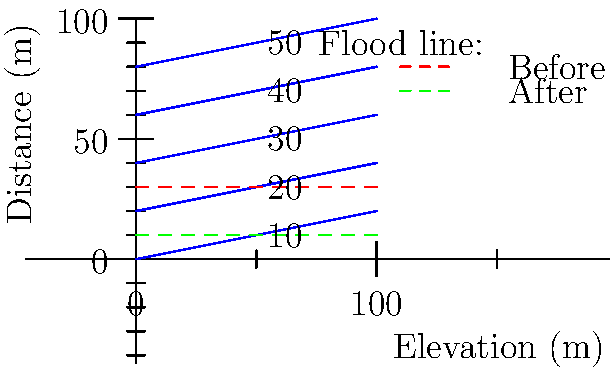Based on the topographical map showing contour lines and flood levels before and after the implementation of a new storm water management system, calculate the reduction in flood risk area (in square meters) for a 100m x 100m property. To calculate the reduction in flood risk area, we need to follow these steps:

1. Determine the flood level before and after the storm water management system:
   - Before: 30m elevation
   - After: 10m elevation

2. Calculate the area affected by flooding before the system:
   - The flood line intersects the 30m contour line
   - Area = $100\text{m} \times 30\text{m} = 3000\text{m}^2$

3. Calculate the area affected by flooding after the system:
   - The flood line intersects the 10m contour line
   - Area = $100\text{m} \times 10\text{m} = 1000\text{m}^2$

4. Calculate the reduction in flood risk area:
   - Reduction = Area before - Area after
   - Reduction = $3000\text{m}^2 - 1000\text{m}^2 = 2000\text{m}^2$

Therefore, the reduction in flood risk area is $2000\text{m}^2$.
Answer: $2000\text{m}^2$ 